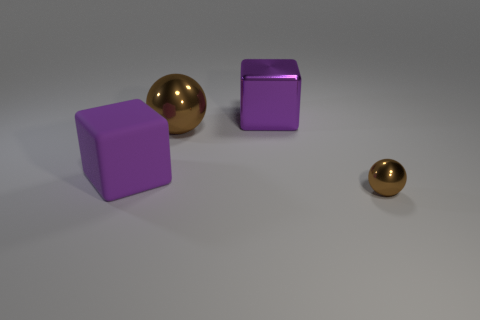Add 4 large blocks. How many objects exist? 8 Add 4 brown spheres. How many brown spheres are left? 6 Add 4 small red matte cylinders. How many small red matte cylinders exist? 4 Subtract 0 green cylinders. How many objects are left? 4 Subtract all purple metal things. Subtract all purple blocks. How many objects are left? 1 